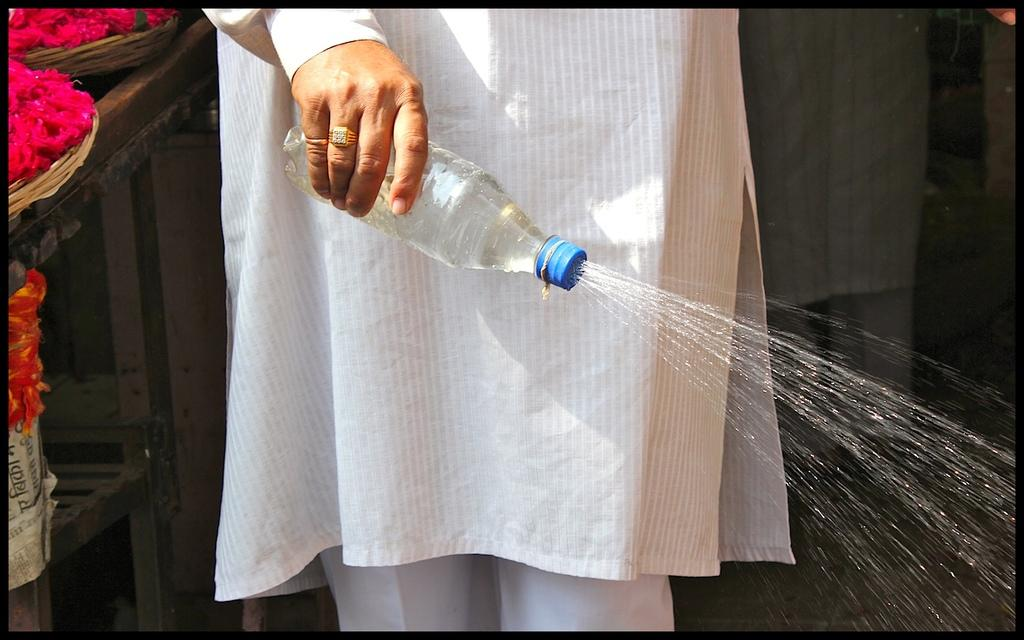Who or what is present in the image? There is a person in the image. What is the person holding in his hand? The person is holding a bottle in his hand. What is happening with the bottle? Water is coming out of the bottle through the cap. What can be seen on the left side of the person? There are rose flowers in baskets on the left side of the person. What type of lipstick is the person applying in the image? There is no lipstick or application of lipstick visible in the image. 